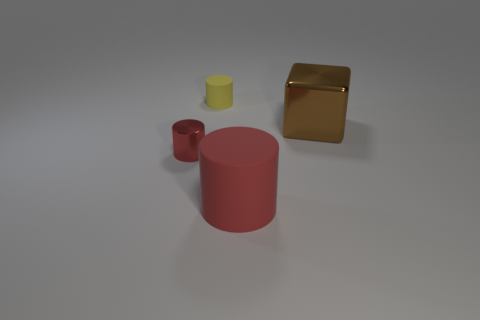Add 4 yellow objects. How many objects exist? 8 Subtract all cylinders. How many objects are left? 1 Add 4 yellow rubber objects. How many yellow rubber objects are left? 5 Add 2 yellow things. How many yellow things exist? 3 Subtract 0 cyan cubes. How many objects are left? 4 Subtract all small yellow rubber cylinders. Subtract all large blue matte cylinders. How many objects are left? 3 